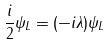Convert formula to latex. <formula><loc_0><loc_0><loc_500><loc_500>\frac { i } { 2 } \psi _ { L } = ( - i \lambda ) \psi _ { L }</formula> 